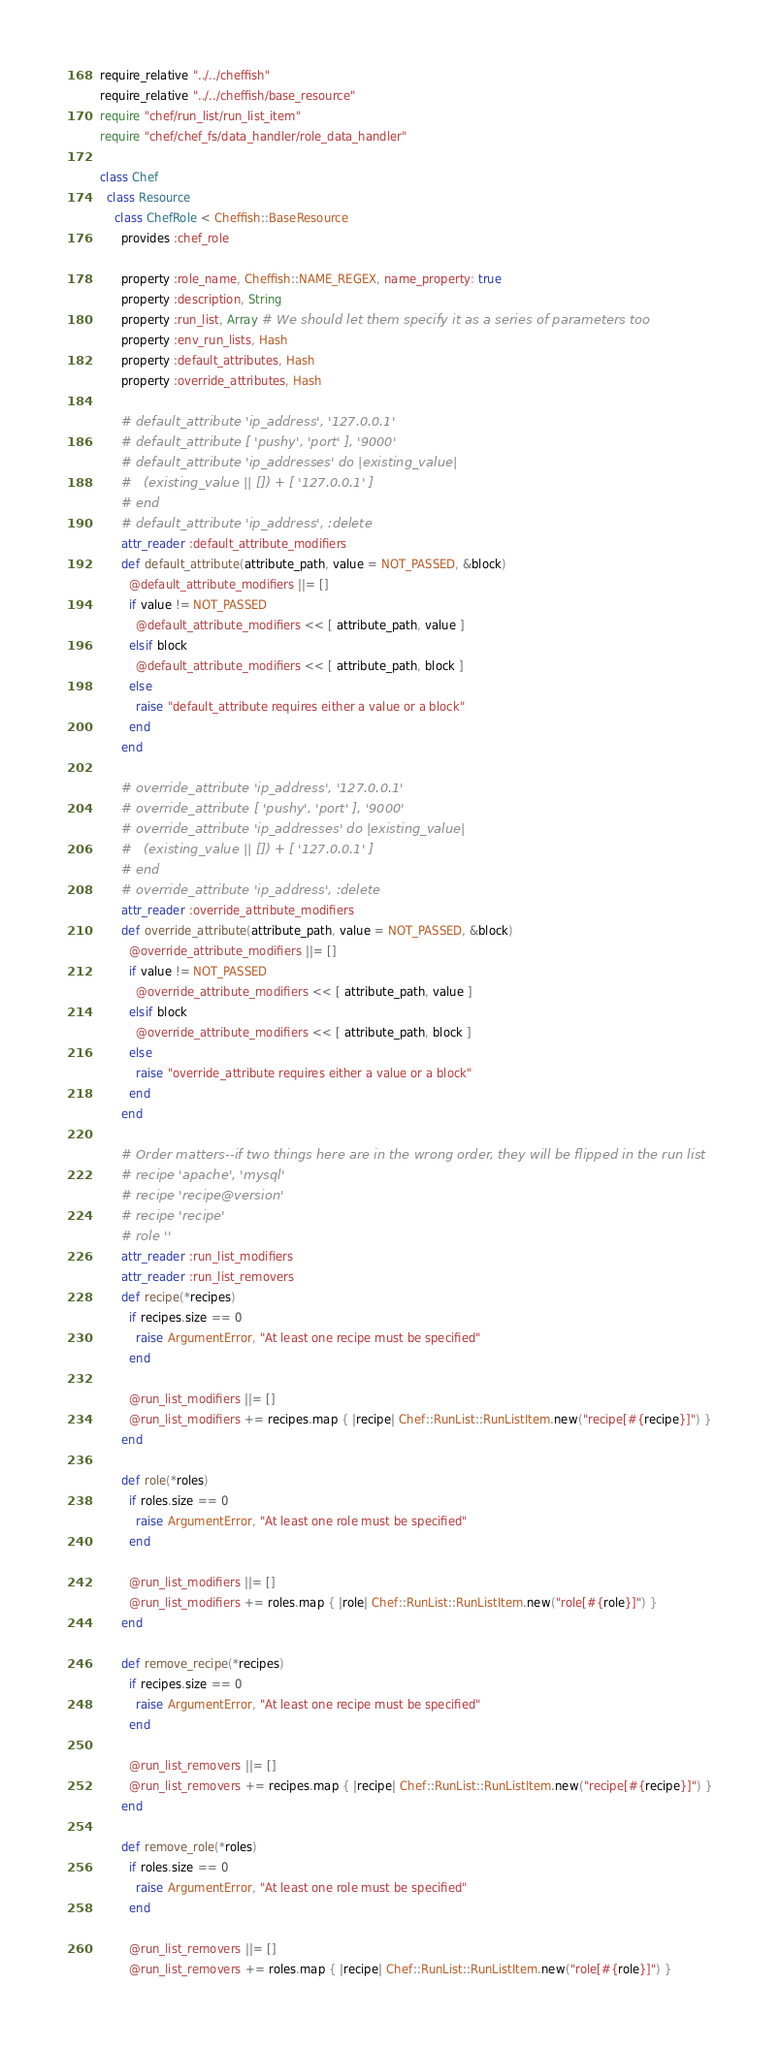Convert code to text. <code><loc_0><loc_0><loc_500><loc_500><_Ruby_>require_relative "../../cheffish"
require_relative "../../cheffish/base_resource"
require "chef/run_list/run_list_item"
require "chef/chef_fs/data_handler/role_data_handler"

class Chef
  class Resource
    class ChefRole < Cheffish::BaseResource
      provides :chef_role

      property :role_name, Cheffish::NAME_REGEX, name_property: true
      property :description, String
      property :run_list, Array # We should let them specify it as a series of parameters too
      property :env_run_lists, Hash
      property :default_attributes, Hash
      property :override_attributes, Hash

      # default_attribute 'ip_address', '127.0.0.1'
      # default_attribute [ 'pushy', 'port' ], '9000'
      # default_attribute 'ip_addresses' do |existing_value|
      #   (existing_value || []) + [ '127.0.0.1' ]
      # end
      # default_attribute 'ip_address', :delete
      attr_reader :default_attribute_modifiers
      def default_attribute(attribute_path, value = NOT_PASSED, &block)
        @default_attribute_modifiers ||= []
        if value != NOT_PASSED
          @default_attribute_modifiers << [ attribute_path, value ]
        elsif block
          @default_attribute_modifiers << [ attribute_path, block ]
        else
          raise "default_attribute requires either a value or a block"
        end
      end

      # override_attribute 'ip_address', '127.0.0.1'
      # override_attribute [ 'pushy', 'port' ], '9000'
      # override_attribute 'ip_addresses' do |existing_value|
      #   (existing_value || []) + [ '127.0.0.1' ]
      # end
      # override_attribute 'ip_address', :delete
      attr_reader :override_attribute_modifiers
      def override_attribute(attribute_path, value = NOT_PASSED, &block)
        @override_attribute_modifiers ||= []
        if value != NOT_PASSED
          @override_attribute_modifiers << [ attribute_path, value ]
        elsif block
          @override_attribute_modifiers << [ attribute_path, block ]
        else
          raise "override_attribute requires either a value or a block"
        end
      end

      # Order matters--if two things here are in the wrong order, they will be flipped in the run list
      # recipe 'apache', 'mysql'
      # recipe 'recipe@version'
      # recipe 'recipe'
      # role ''
      attr_reader :run_list_modifiers
      attr_reader :run_list_removers
      def recipe(*recipes)
        if recipes.size == 0
          raise ArgumentError, "At least one recipe must be specified"
        end

        @run_list_modifiers ||= []
        @run_list_modifiers += recipes.map { |recipe| Chef::RunList::RunListItem.new("recipe[#{recipe}]") }
      end

      def role(*roles)
        if roles.size == 0
          raise ArgumentError, "At least one role must be specified"
        end

        @run_list_modifiers ||= []
        @run_list_modifiers += roles.map { |role| Chef::RunList::RunListItem.new("role[#{role}]") }
      end

      def remove_recipe(*recipes)
        if recipes.size == 0
          raise ArgumentError, "At least one recipe must be specified"
        end

        @run_list_removers ||= []
        @run_list_removers += recipes.map { |recipe| Chef::RunList::RunListItem.new("recipe[#{recipe}]") }
      end

      def remove_role(*roles)
        if roles.size == 0
          raise ArgumentError, "At least one role must be specified"
        end

        @run_list_removers ||= []
        @run_list_removers += roles.map { |recipe| Chef::RunList::RunListItem.new("role[#{role}]") }</code> 